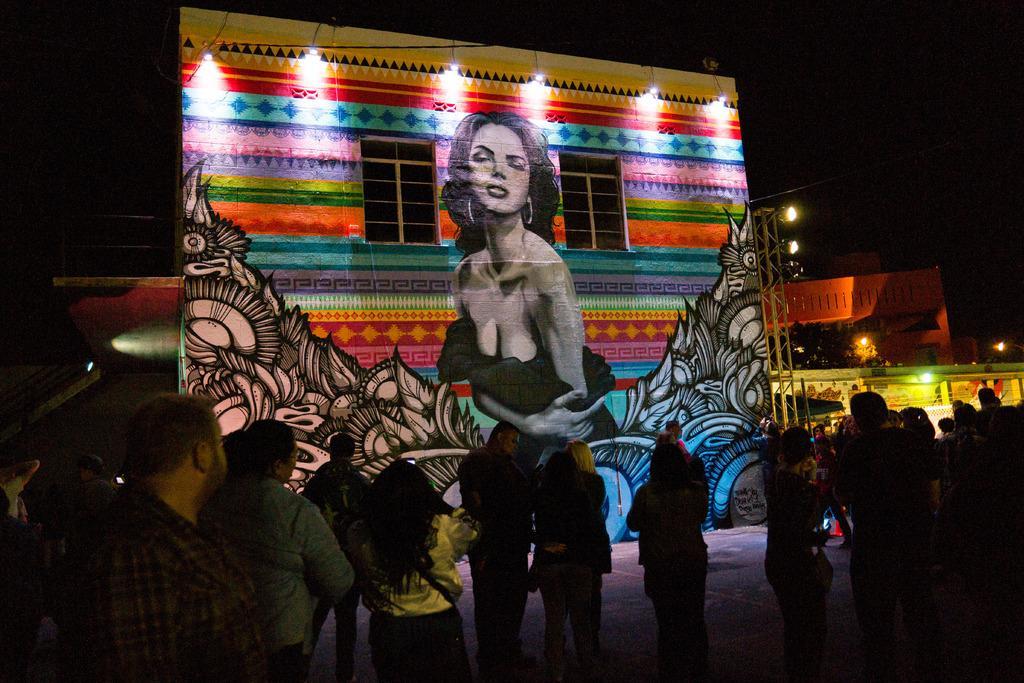Could you give a brief overview of what you see in this image? In this picture we can see a group of people standing on the ground. In front of the people, there is a painting of a woman and some designs on the wall and to the wall there are windows and lights. On the right side of the wall, there is a truss. On the left side of the image, there is an object. On the right side of the image, there are lights, a building and a tree. Behind the building, there is a dark background. 